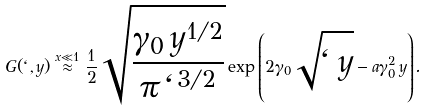<formula> <loc_0><loc_0><loc_500><loc_500>G ( \ell , y ) \stackrel { x \ll 1 } { \approx } \frac { 1 } { 2 } \sqrt { \frac { \gamma _ { 0 } \, y ^ { 1 / 2 } } { { \pi \, \ell ^ { 3 / 2 } } } } \exp { \left ( 2 \gamma _ { 0 } \sqrt { \ell \, y } - a \gamma _ { 0 } ^ { 2 } \, y \right ) } .</formula> 